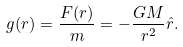Convert formula to latex. <formula><loc_0><loc_0><loc_500><loc_500>g ( r ) = { \frac { F ( r ) } { m } } = - { \frac { G M } { r ^ { 2 } } } { \hat { r } } .</formula> 